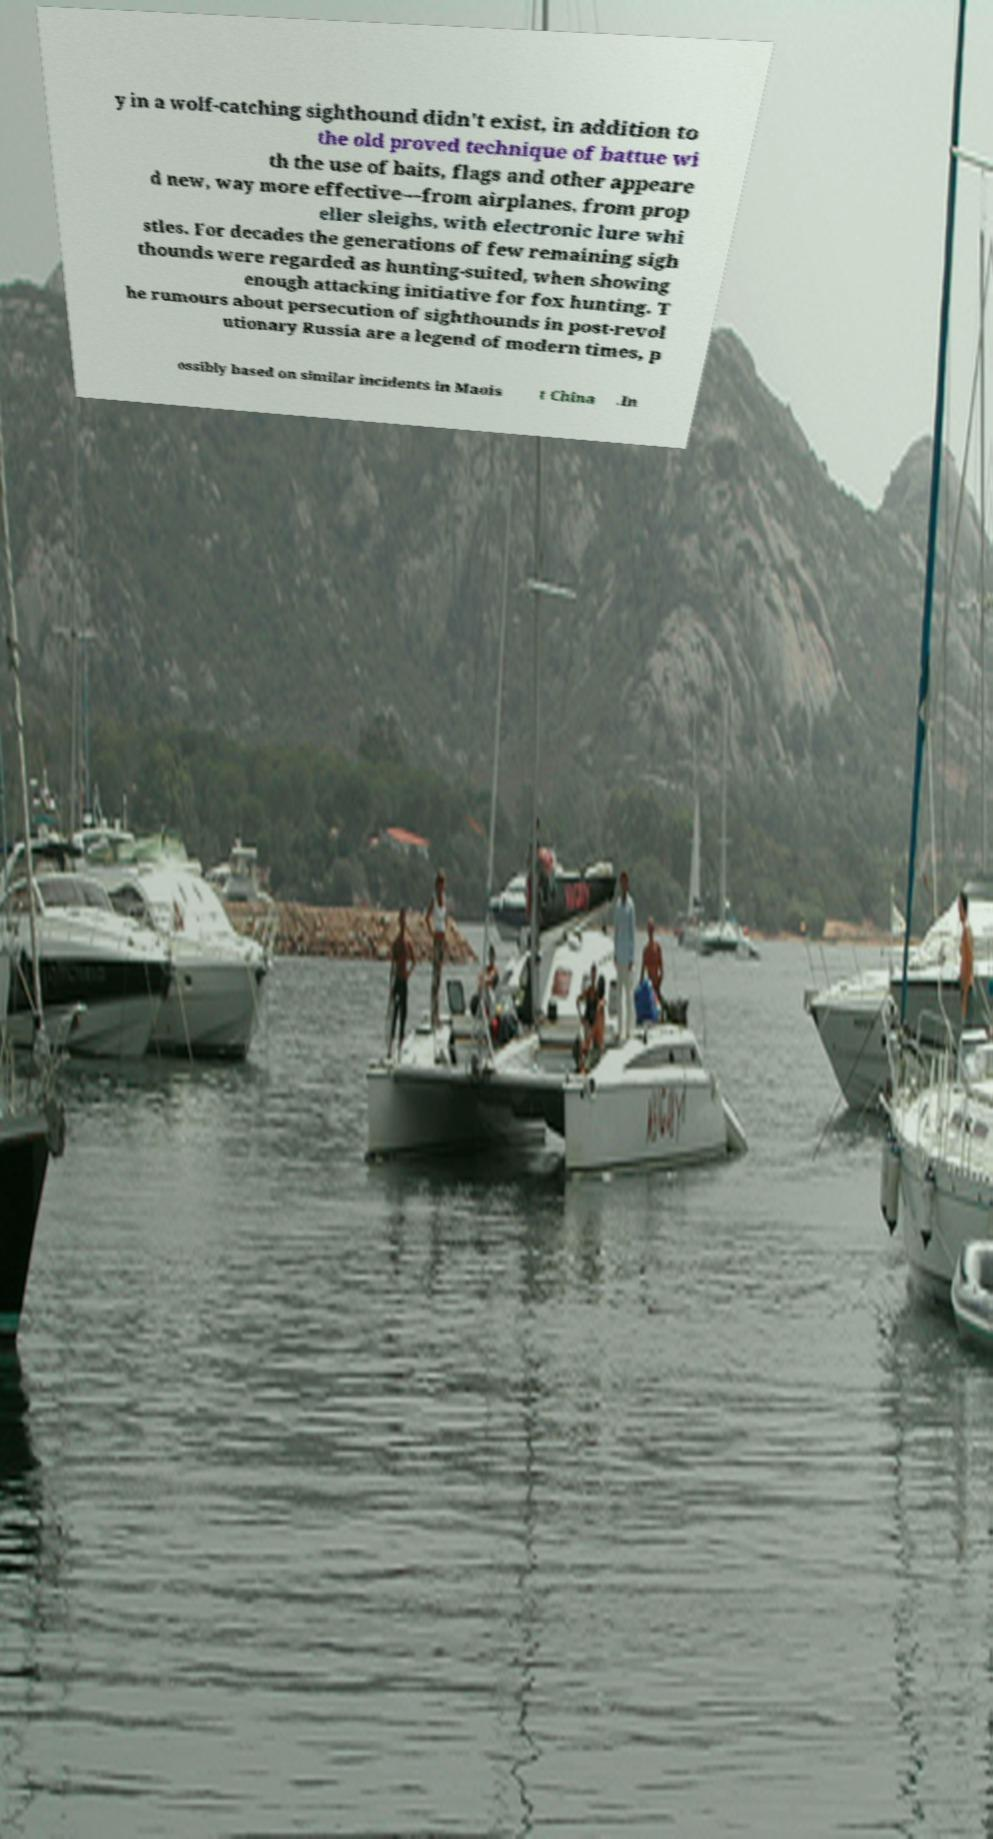There's text embedded in this image that I need extracted. Can you transcribe it verbatim? y in a wolf-catching sighthound didn't exist, in addition to the old proved technique of battue wi th the use of baits, flags and other appeare d new, way more effective—from airplanes, from prop eller sleighs, with electronic lure whi stles. For decades the generations of few remaining sigh thounds were regarded as hunting-suited, when showing enough attacking initiative for fox hunting. T he rumours about persecution of sighthounds in post-revol utionary Russia are a legend of modern times, p ossibly based on similar incidents in Maois t China .In 